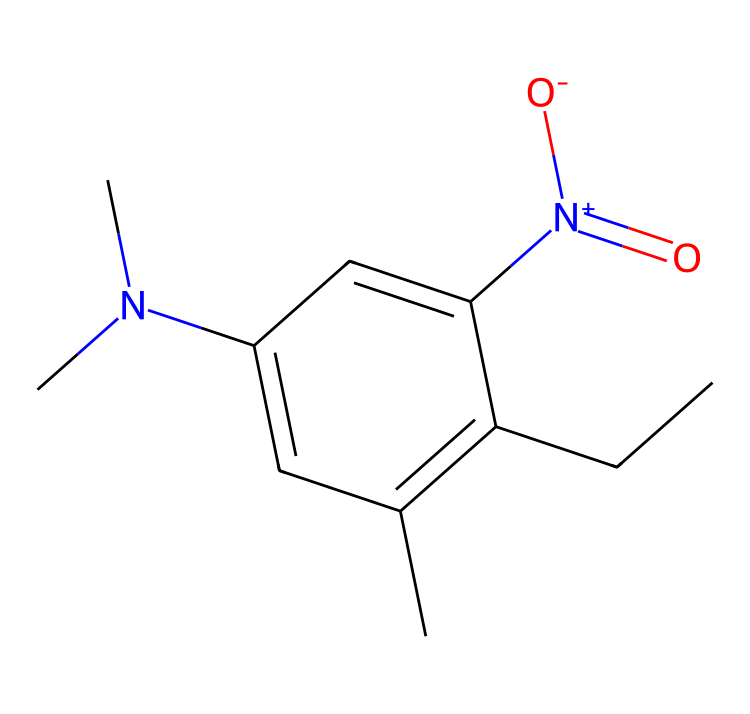How many carbon atoms are in pendimethalin? By analyzing the provided SMILES representation, we count the 'C' characters, which indicate carbon atoms. The structure shows 10 carbon atoms.
Answer: 10 What is the functional group present in this herbicide? The nitrogen atom with a positive charge and a nitro group indicated by '[N+](=O)[O-]' is a distinct functional group, representing a nitro group within the structure.
Answer: nitro group How many nitrogen atoms are present in the chemical structure? The SMILES representation contains two nitrogen symbols 'N', indicating the presence of two nitrogen atoms in the compound.
Answer: 2 What type of herbicide is pendimethalin classified as? Since pendimethalin acts before the emergence of weeds, it is classified as a pre-emergence herbicide.
Answer: pre-emergence What distinguishes this chemical structure from others in its class? The unique combination of the aromatic system and specifically the presence of the nitro group alongside aliphatic carbon chains contribute to the herbicidal activity, setting it apart from other herbicides.
Answer: unique structure What does the ‘N(C)C’ denote in terms of molecular structure? The notation 'N(C)C' shows the presence of a nitrogen atom bonded to two methyl groups, representing a dimethylamino group which is significant in herbicidal activity.
Answer: dimethylamino group What is the expected solubility of pendimethalin due to its structure? Based on its chemical characteristics, particularly the presence of non-polar hydrocarbons, we can infer that pendimethalin is likely to be moderately soluble in organic solvents but less so in water.
Answer: moderate solubility 